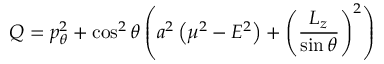<formula> <loc_0><loc_0><loc_500><loc_500>Q = p _ { \theta } ^ { 2 } + \cos ^ { 2 } \theta \left ( a ^ { 2 } \left ( \mu ^ { 2 } - E ^ { 2 } \right ) + \left ( { \frac { L _ { z } } { \sin \theta } } \right ) ^ { 2 } \right )</formula> 